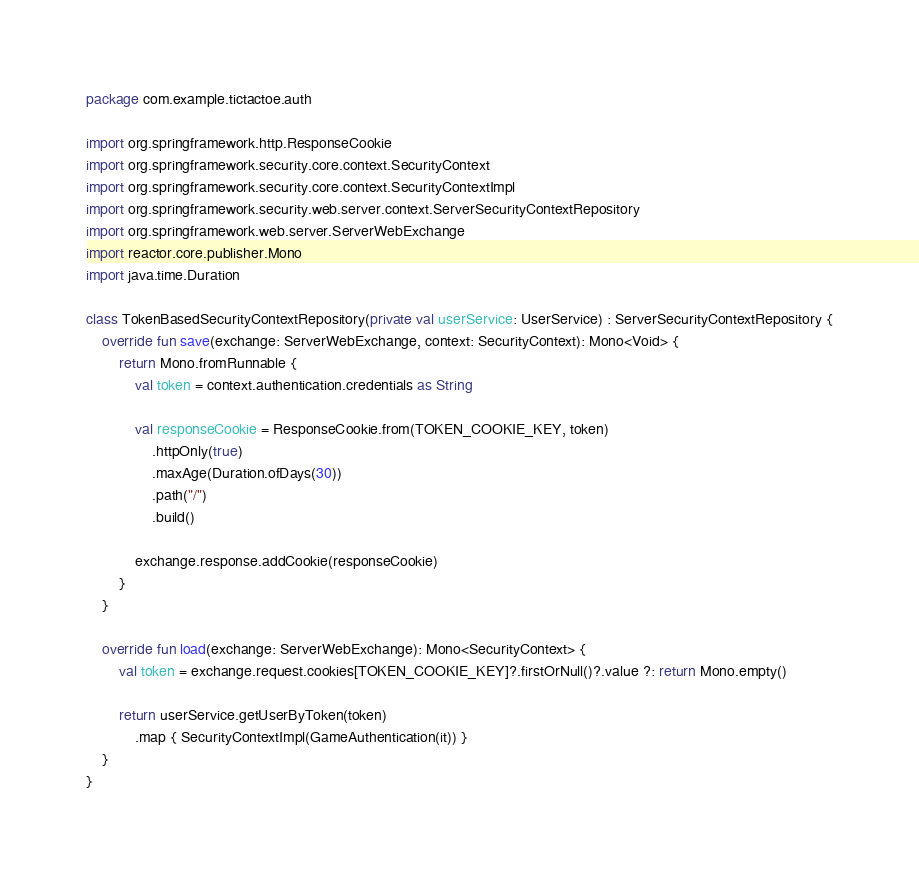<code> <loc_0><loc_0><loc_500><loc_500><_Kotlin_>package com.example.tictactoe.auth

import org.springframework.http.ResponseCookie
import org.springframework.security.core.context.SecurityContext
import org.springframework.security.core.context.SecurityContextImpl
import org.springframework.security.web.server.context.ServerSecurityContextRepository
import org.springframework.web.server.ServerWebExchange
import reactor.core.publisher.Mono
import java.time.Duration

class TokenBasedSecurityContextRepository(private val userService: UserService) : ServerSecurityContextRepository {
    override fun save(exchange: ServerWebExchange, context: SecurityContext): Mono<Void> {
        return Mono.fromRunnable {
            val token = context.authentication.credentials as String

            val responseCookie = ResponseCookie.from(TOKEN_COOKIE_KEY, token)
                .httpOnly(true)
                .maxAge(Duration.ofDays(30))
                .path("/")
                .build()

            exchange.response.addCookie(responseCookie)
        }
    }

    override fun load(exchange: ServerWebExchange): Mono<SecurityContext> {
        val token = exchange.request.cookies[TOKEN_COOKIE_KEY]?.firstOrNull()?.value ?: return Mono.empty()

        return userService.getUserByToken(token)
            .map { SecurityContextImpl(GameAuthentication(it)) }
    }
}</code> 